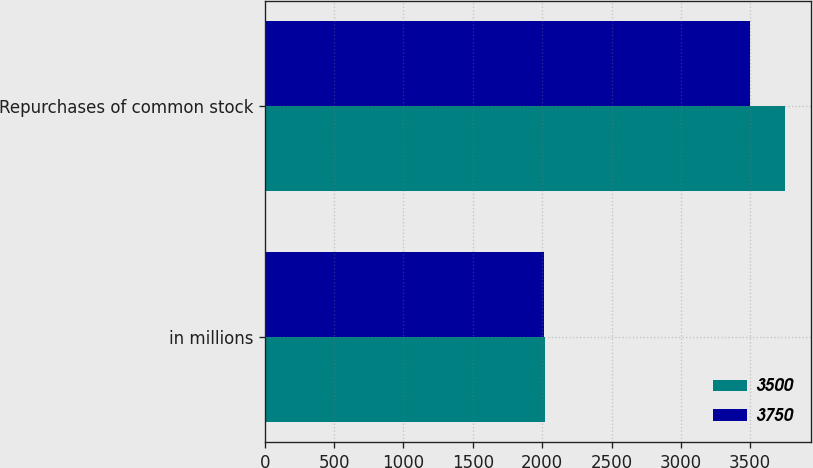Convert chart to OTSL. <chart><loc_0><loc_0><loc_500><loc_500><stacked_bar_chart><ecel><fcel>in millions<fcel>Repurchases of common stock<nl><fcel>3500<fcel>2017<fcel>3750<nl><fcel>3750<fcel>2016<fcel>3500<nl></chart> 